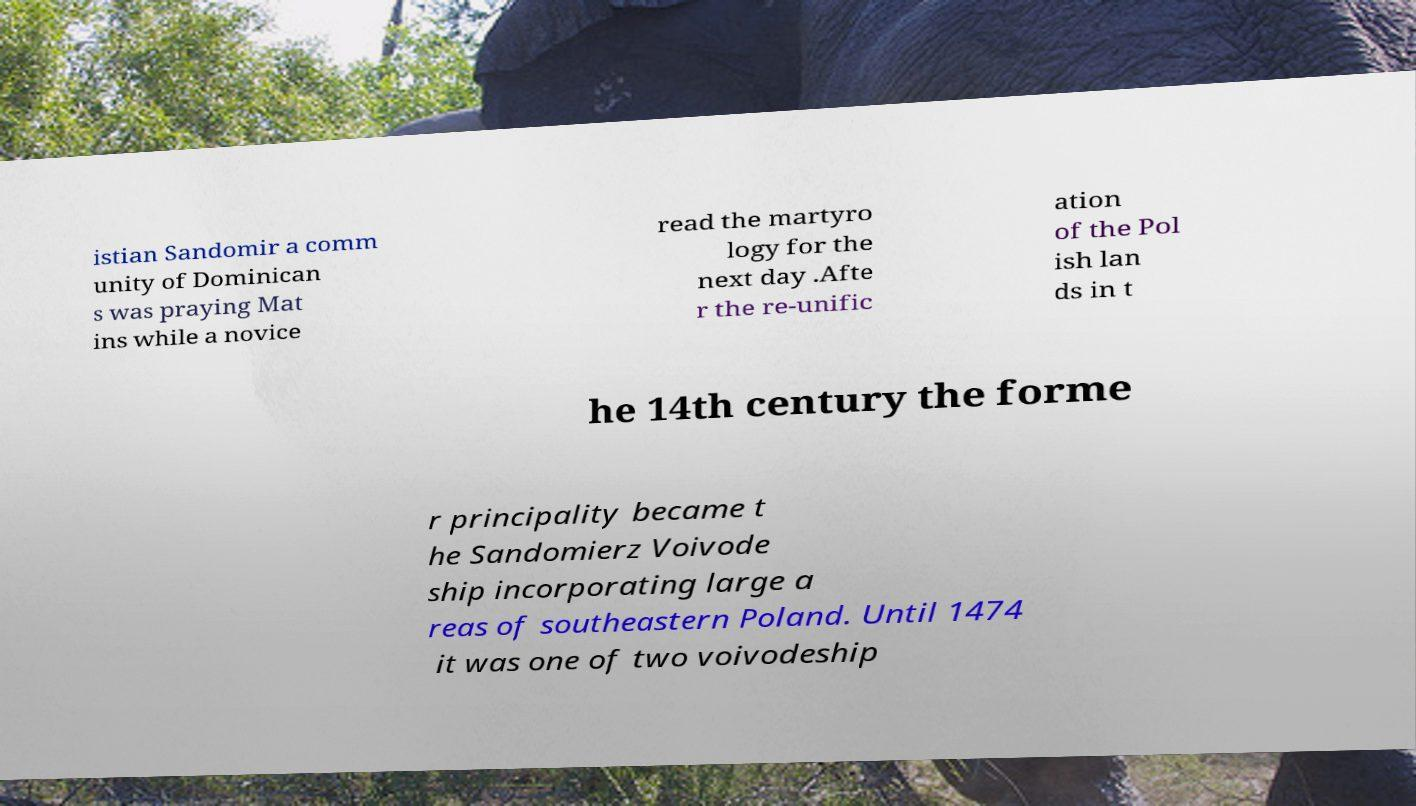What messages or text are displayed in this image? I need them in a readable, typed format. istian Sandomir a comm unity of Dominican s was praying Mat ins while a novice read the martyro logy for the next day .Afte r the re-unific ation of the Pol ish lan ds in t he 14th century the forme r principality became t he Sandomierz Voivode ship incorporating large a reas of southeastern Poland. Until 1474 it was one of two voivodeship 